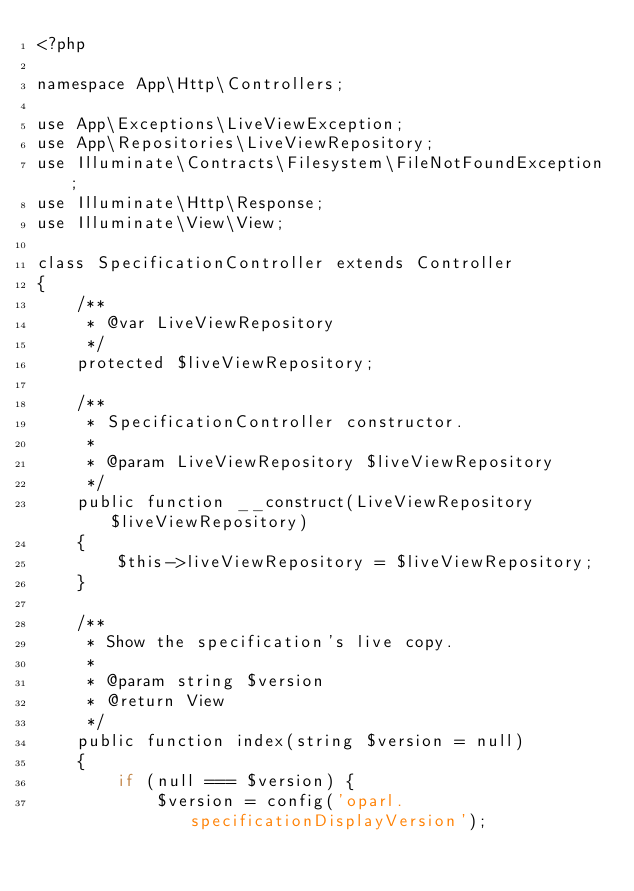Convert code to text. <code><loc_0><loc_0><loc_500><loc_500><_PHP_><?php

namespace App\Http\Controllers;

use App\Exceptions\LiveViewException;
use App\Repositories\LiveViewRepository;
use Illuminate\Contracts\Filesystem\FileNotFoundException;
use Illuminate\Http\Response;
use Illuminate\View\View;

class SpecificationController extends Controller
{
    /**
     * @var LiveViewRepository
     */
    protected $liveViewRepository;

    /**
     * SpecificationController constructor.
     *
     * @param LiveViewRepository $liveViewRepository
     */
    public function __construct(LiveViewRepository $liveViewRepository)
    {
        $this->liveViewRepository = $liveViewRepository;
    }

    /**
     * Show the specification's live copy.
     *
     * @param string $version
     * @return View
     */
    public function index(string $version = null)
    {
        if (null === $version) {
            $version = config('oparl.specificationDisplayVersion');</code> 